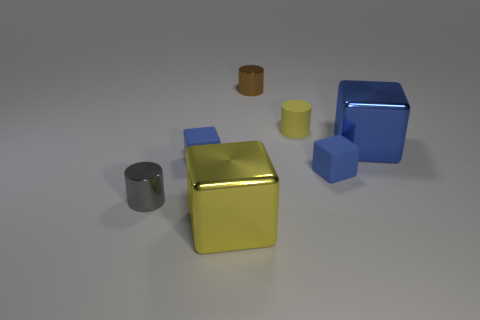Subtract all brown cylinders. How many blue blocks are left? 3 Add 3 small yellow cylinders. How many objects exist? 10 Subtract all cubes. How many objects are left? 3 Add 4 small metallic cylinders. How many small metallic cylinders are left? 6 Add 5 blue shiny blocks. How many blue shiny blocks exist? 6 Subtract 0 cyan cylinders. How many objects are left? 7 Subtract all brown things. Subtract all small yellow cylinders. How many objects are left? 5 